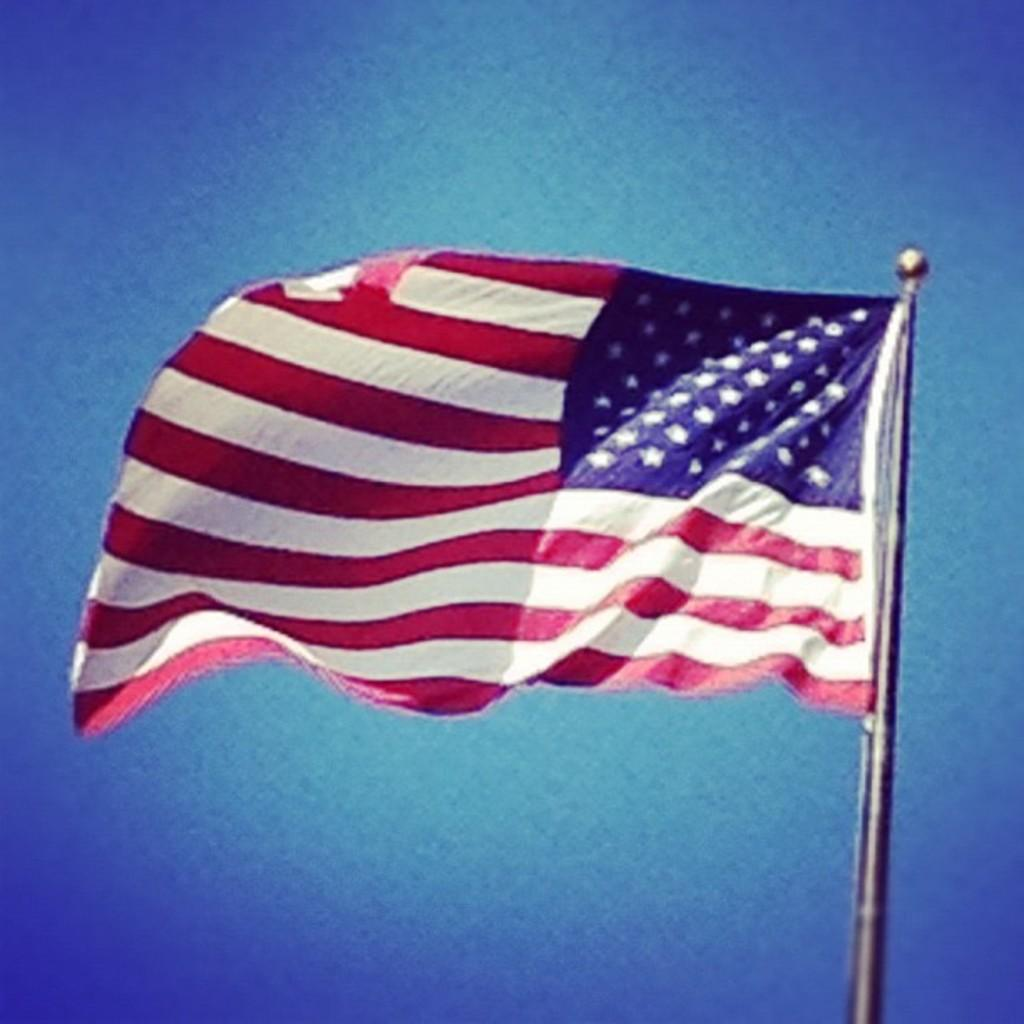What is the main object in the image? There is a pole in the image. What is attached to the pole? There is a flag on the pole. What color is predominant in the background of the image? The background of the image has a blue color. Can you see any honey dripping from the flag in the image? There is no honey present in the image, and therefore no honey can be seen dripping from the flag. 